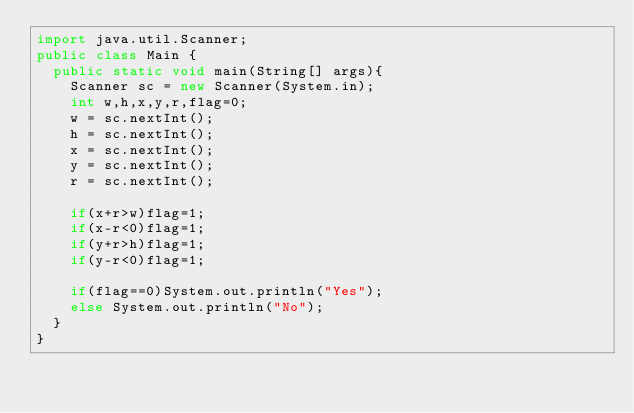Convert code to text. <code><loc_0><loc_0><loc_500><loc_500><_Java_>import java.util.Scanner;
public class Main {
	public static void main(String[] args){
		Scanner sc = new Scanner(System.in);
		int w,h,x,y,r,flag=0;
		w = sc.nextInt();
		h = sc.nextInt();
		x = sc.nextInt();
		y = sc.nextInt();
		r = sc.nextInt();
		
		if(x+r>w)flag=1;
		if(x-r<0)flag=1;
		if(y+r>h)flag=1;
		if(y-r<0)flag=1;
		
		if(flag==0)System.out.println("Yes");
		else System.out.println("No");
	}
}

</code> 